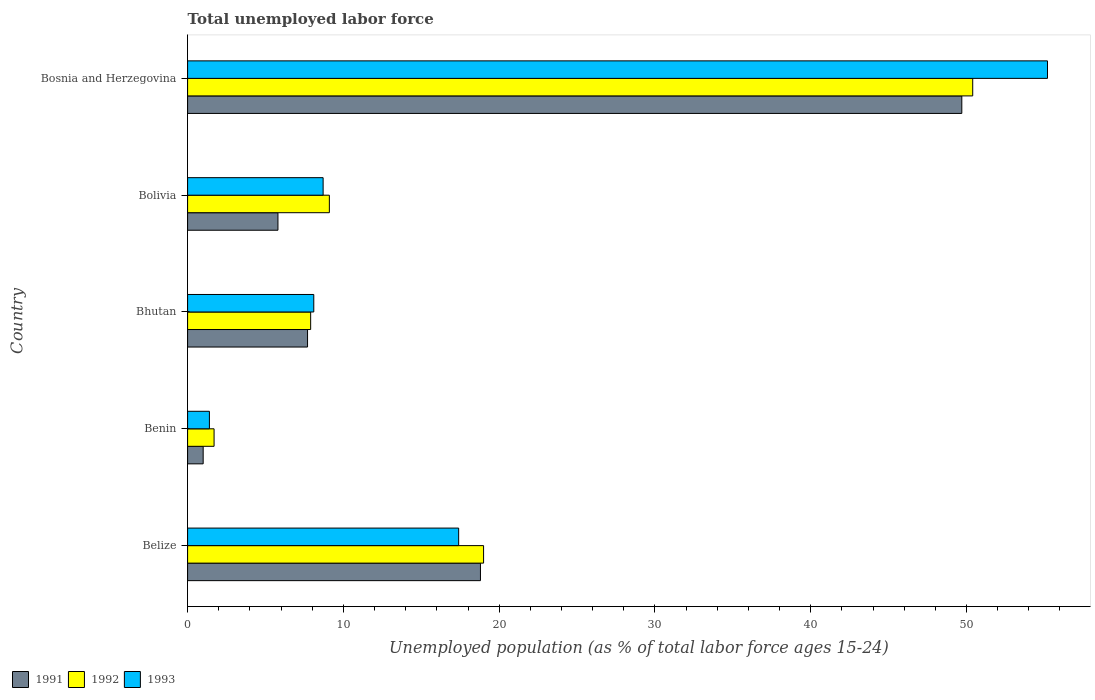How many bars are there on the 4th tick from the top?
Offer a terse response. 3. How many bars are there on the 5th tick from the bottom?
Offer a very short reply. 3. What is the label of the 4th group of bars from the top?
Provide a short and direct response. Benin. In how many cases, is the number of bars for a given country not equal to the number of legend labels?
Make the answer very short. 0. What is the percentage of unemployed population in in 1992 in Bosnia and Herzegovina?
Make the answer very short. 50.4. Across all countries, what is the maximum percentage of unemployed population in in 1991?
Offer a terse response. 49.7. In which country was the percentage of unemployed population in in 1992 maximum?
Make the answer very short. Bosnia and Herzegovina. In which country was the percentage of unemployed population in in 1991 minimum?
Provide a short and direct response. Benin. What is the total percentage of unemployed population in in 1993 in the graph?
Your response must be concise. 90.8. What is the difference between the percentage of unemployed population in in 1992 in Belize and that in Bolivia?
Keep it short and to the point. 9.9. What is the difference between the percentage of unemployed population in in 1992 in Bolivia and the percentage of unemployed population in in 1991 in Benin?
Provide a succinct answer. 8.1. What is the difference between the percentage of unemployed population in in 1993 and percentage of unemployed population in in 1991 in Belize?
Offer a terse response. -1.4. What is the ratio of the percentage of unemployed population in in 1993 in Benin to that in Bosnia and Herzegovina?
Your response must be concise. 0.03. Is the percentage of unemployed population in in 1991 in Belize less than that in Benin?
Offer a very short reply. No. What is the difference between the highest and the second highest percentage of unemployed population in in 1992?
Make the answer very short. 31.4. What is the difference between the highest and the lowest percentage of unemployed population in in 1993?
Make the answer very short. 53.8. In how many countries, is the percentage of unemployed population in in 1992 greater than the average percentage of unemployed population in in 1992 taken over all countries?
Ensure brevity in your answer.  2. Is the sum of the percentage of unemployed population in in 1991 in Belize and Benin greater than the maximum percentage of unemployed population in in 1992 across all countries?
Offer a terse response. No. What does the 2nd bar from the top in Belize represents?
Give a very brief answer. 1992. What does the 1st bar from the bottom in Bolivia represents?
Offer a very short reply. 1991. Are all the bars in the graph horizontal?
Ensure brevity in your answer.  Yes. How many countries are there in the graph?
Offer a very short reply. 5. What is the difference between two consecutive major ticks on the X-axis?
Ensure brevity in your answer.  10. Does the graph contain any zero values?
Make the answer very short. No. Where does the legend appear in the graph?
Make the answer very short. Bottom left. How many legend labels are there?
Give a very brief answer. 3. What is the title of the graph?
Make the answer very short. Total unemployed labor force. Does "2006" appear as one of the legend labels in the graph?
Offer a terse response. No. What is the label or title of the X-axis?
Make the answer very short. Unemployed population (as % of total labor force ages 15-24). What is the label or title of the Y-axis?
Ensure brevity in your answer.  Country. What is the Unemployed population (as % of total labor force ages 15-24) of 1991 in Belize?
Offer a terse response. 18.8. What is the Unemployed population (as % of total labor force ages 15-24) of 1992 in Belize?
Provide a succinct answer. 19. What is the Unemployed population (as % of total labor force ages 15-24) of 1993 in Belize?
Offer a very short reply. 17.4. What is the Unemployed population (as % of total labor force ages 15-24) in 1992 in Benin?
Offer a very short reply. 1.7. What is the Unemployed population (as % of total labor force ages 15-24) of 1993 in Benin?
Give a very brief answer. 1.4. What is the Unemployed population (as % of total labor force ages 15-24) in 1991 in Bhutan?
Provide a succinct answer. 7.7. What is the Unemployed population (as % of total labor force ages 15-24) of 1992 in Bhutan?
Your response must be concise. 7.9. What is the Unemployed population (as % of total labor force ages 15-24) in 1993 in Bhutan?
Provide a short and direct response. 8.1. What is the Unemployed population (as % of total labor force ages 15-24) in 1991 in Bolivia?
Your answer should be compact. 5.8. What is the Unemployed population (as % of total labor force ages 15-24) of 1992 in Bolivia?
Offer a very short reply. 9.1. What is the Unemployed population (as % of total labor force ages 15-24) in 1993 in Bolivia?
Your answer should be compact. 8.7. What is the Unemployed population (as % of total labor force ages 15-24) in 1991 in Bosnia and Herzegovina?
Give a very brief answer. 49.7. What is the Unemployed population (as % of total labor force ages 15-24) of 1992 in Bosnia and Herzegovina?
Make the answer very short. 50.4. What is the Unemployed population (as % of total labor force ages 15-24) of 1993 in Bosnia and Herzegovina?
Provide a short and direct response. 55.2. Across all countries, what is the maximum Unemployed population (as % of total labor force ages 15-24) in 1991?
Make the answer very short. 49.7. Across all countries, what is the maximum Unemployed population (as % of total labor force ages 15-24) of 1992?
Give a very brief answer. 50.4. Across all countries, what is the maximum Unemployed population (as % of total labor force ages 15-24) in 1993?
Make the answer very short. 55.2. Across all countries, what is the minimum Unemployed population (as % of total labor force ages 15-24) of 1991?
Provide a short and direct response. 1. Across all countries, what is the minimum Unemployed population (as % of total labor force ages 15-24) in 1992?
Keep it short and to the point. 1.7. Across all countries, what is the minimum Unemployed population (as % of total labor force ages 15-24) in 1993?
Offer a very short reply. 1.4. What is the total Unemployed population (as % of total labor force ages 15-24) of 1992 in the graph?
Keep it short and to the point. 88.1. What is the total Unemployed population (as % of total labor force ages 15-24) of 1993 in the graph?
Ensure brevity in your answer.  90.8. What is the difference between the Unemployed population (as % of total labor force ages 15-24) in 1991 in Belize and that in Benin?
Offer a very short reply. 17.8. What is the difference between the Unemployed population (as % of total labor force ages 15-24) of 1992 in Belize and that in Benin?
Provide a short and direct response. 17.3. What is the difference between the Unemployed population (as % of total labor force ages 15-24) in 1992 in Belize and that in Bhutan?
Offer a terse response. 11.1. What is the difference between the Unemployed population (as % of total labor force ages 15-24) of 1993 in Belize and that in Bhutan?
Your answer should be compact. 9.3. What is the difference between the Unemployed population (as % of total labor force ages 15-24) in 1992 in Belize and that in Bolivia?
Offer a very short reply. 9.9. What is the difference between the Unemployed population (as % of total labor force ages 15-24) in 1991 in Belize and that in Bosnia and Herzegovina?
Offer a very short reply. -30.9. What is the difference between the Unemployed population (as % of total labor force ages 15-24) in 1992 in Belize and that in Bosnia and Herzegovina?
Provide a short and direct response. -31.4. What is the difference between the Unemployed population (as % of total labor force ages 15-24) of 1993 in Belize and that in Bosnia and Herzegovina?
Keep it short and to the point. -37.8. What is the difference between the Unemployed population (as % of total labor force ages 15-24) in 1992 in Benin and that in Bhutan?
Ensure brevity in your answer.  -6.2. What is the difference between the Unemployed population (as % of total labor force ages 15-24) in 1993 in Benin and that in Bhutan?
Provide a succinct answer. -6.7. What is the difference between the Unemployed population (as % of total labor force ages 15-24) of 1991 in Benin and that in Bolivia?
Give a very brief answer. -4.8. What is the difference between the Unemployed population (as % of total labor force ages 15-24) in 1992 in Benin and that in Bolivia?
Offer a terse response. -7.4. What is the difference between the Unemployed population (as % of total labor force ages 15-24) in 1993 in Benin and that in Bolivia?
Your response must be concise. -7.3. What is the difference between the Unemployed population (as % of total labor force ages 15-24) of 1991 in Benin and that in Bosnia and Herzegovina?
Your answer should be very brief. -48.7. What is the difference between the Unemployed population (as % of total labor force ages 15-24) of 1992 in Benin and that in Bosnia and Herzegovina?
Provide a succinct answer. -48.7. What is the difference between the Unemployed population (as % of total labor force ages 15-24) of 1993 in Benin and that in Bosnia and Herzegovina?
Ensure brevity in your answer.  -53.8. What is the difference between the Unemployed population (as % of total labor force ages 15-24) in 1991 in Bhutan and that in Bolivia?
Your response must be concise. 1.9. What is the difference between the Unemployed population (as % of total labor force ages 15-24) of 1992 in Bhutan and that in Bolivia?
Keep it short and to the point. -1.2. What is the difference between the Unemployed population (as % of total labor force ages 15-24) in 1991 in Bhutan and that in Bosnia and Herzegovina?
Your response must be concise. -42. What is the difference between the Unemployed population (as % of total labor force ages 15-24) of 1992 in Bhutan and that in Bosnia and Herzegovina?
Give a very brief answer. -42.5. What is the difference between the Unemployed population (as % of total labor force ages 15-24) in 1993 in Bhutan and that in Bosnia and Herzegovina?
Keep it short and to the point. -47.1. What is the difference between the Unemployed population (as % of total labor force ages 15-24) of 1991 in Bolivia and that in Bosnia and Herzegovina?
Your answer should be compact. -43.9. What is the difference between the Unemployed population (as % of total labor force ages 15-24) of 1992 in Bolivia and that in Bosnia and Herzegovina?
Make the answer very short. -41.3. What is the difference between the Unemployed population (as % of total labor force ages 15-24) of 1993 in Bolivia and that in Bosnia and Herzegovina?
Give a very brief answer. -46.5. What is the difference between the Unemployed population (as % of total labor force ages 15-24) in 1991 in Belize and the Unemployed population (as % of total labor force ages 15-24) in 1992 in Benin?
Give a very brief answer. 17.1. What is the difference between the Unemployed population (as % of total labor force ages 15-24) in 1991 in Belize and the Unemployed population (as % of total labor force ages 15-24) in 1993 in Benin?
Ensure brevity in your answer.  17.4. What is the difference between the Unemployed population (as % of total labor force ages 15-24) in 1992 in Belize and the Unemployed population (as % of total labor force ages 15-24) in 1993 in Benin?
Provide a short and direct response. 17.6. What is the difference between the Unemployed population (as % of total labor force ages 15-24) of 1991 in Belize and the Unemployed population (as % of total labor force ages 15-24) of 1992 in Bhutan?
Make the answer very short. 10.9. What is the difference between the Unemployed population (as % of total labor force ages 15-24) in 1991 in Belize and the Unemployed population (as % of total labor force ages 15-24) in 1993 in Bolivia?
Ensure brevity in your answer.  10.1. What is the difference between the Unemployed population (as % of total labor force ages 15-24) in 1991 in Belize and the Unemployed population (as % of total labor force ages 15-24) in 1992 in Bosnia and Herzegovina?
Provide a succinct answer. -31.6. What is the difference between the Unemployed population (as % of total labor force ages 15-24) of 1991 in Belize and the Unemployed population (as % of total labor force ages 15-24) of 1993 in Bosnia and Herzegovina?
Give a very brief answer. -36.4. What is the difference between the Unemployed population (as % of total labor force ages 15-24) in 1992 in Belize and the Unemployed population (as % of total labor force ages 15-24) in 1993 in Bosnia and Herzegovina?
Your answer should be very brief. -36.2. What is the difference between the Unemployed population (as % of total labor force ages 15-24) in 1991 in Benin and the Unemployed population (as % of total labor force ages 15-24) in 1992 in Bhutan?
Offer a terse response. -6.9. What is the difference between the Unemployed population (as % of total labor force ages 15-24) in 1991 in Benin and the Unemployed population (as % of total labor force ages 15-24) in 1992 in Bolivia?
Offer a terse response. -8.1. What is the difference between the Unemployed population (as % of total labor force ages 15-24) in 1991 in Benin and the Unemployed population (as % of total labor force ages 15-24) in 1993 in Bolivia?
Your response must be concise. -7.7. What is the difference between the Unemployed population (as % of total labor force ages 15-24) in 1992 in Benin and the Unemployed population (as % of total labor force ages 15-24) in 1993 in Bolivia?
Offer a terse response. -7. What is the difference between the Unemployed population (as % of total labor force ages 15-24) in 1991 in Benin and the Unemployed population (as % of total labor force ages 15-24) in 1992 in Bosnia and Herzegovina?
Offer a terse response. -49.4. What is the difference between the Unemployed population (as % of total labor force ages 15-24) of 1991 in Benin and the Unemployed population (as % of total labor force ages 15-24) of 1993 in Bosnia and Herzegovina?
Ensure brevity in your answer.  -54.2. What is the difference between the Unemployed population (as % of total labor force ages 15-24) of 1992 in Benin and the Unemployed population (as % of total labor force ages 15-24) of 1993 in Bosnia and Herzegovina?
Offer a terse response. -53.5. What is the difference between the Unemployed population (as % of total labor force ages 15-24) of 1991 in Bhutan and the Unemployed population (as % of total labor force ages 15-24) of 1992 in Bolivia?
Your response must be concise. -1.4. What is the difference between the Unemployed population (as % of total labor force ages 15-24) of 1991 in Bhutan and the Unemployed population (as % of total labor force ages 15-24) of 1992 in Bosnia and Herzegovina?
Provide a succinct answer. -42.7. What is the difference between the Unemployed population (as % of total labor force ages 15-24) of 1991 in Bhutan and the Unemployed population (as % of total labor force ages 15-24) of 1993 in Bosnia and Herzegovina?
Ensure brevity in your answer.  -47.5. What is the difference between the Unemployed population (as % of total labor force ages 15-24) in 1992 in Bhutan and the Unemployed population (as % of total labor force ages 15-24) in 1993 in Bosnia and Herzegovina?
Provide a succinct answer. -47.3. What is the difference between the Unemployed population (as % of total labor force ages 15-24) of 1991 in Bolivia and the Unemployed population (as % of total labor force ages 15-24) of 1992 in Bosnia and Herzegovina?
Give a very brief answer. -44.6. What is the difference between the Unemployed population (as % of total labor force ages 15-24) of 1991 in Bolivia and the Unemployed population (as % of total labor force ages 15-24) of 1993 in Bosnia and Herzegovina?
Provide a succinct answer. -49.4. What is the difference between the Unemployed population (as % of total labor force ages 15-24) of 1992 in Bolivia and the Unemployed population (as % of total labor force ages 15-24) of 1993 in Bosnia and Herzegovina?
Offer a very short reply. -46.1. What is the average Unemployed population (as % of total labor force ages 15-24) of 1992 per country?
Give a very brief answer. 17.62. What is the average Unemployed population (as % of total labor force ages 15-24) of 1993 per country?
Your answer should be very brief. 18.16. What is the difference between the Unemployed population (as % of total labor force ages 15-24) in 1991 and Unemployed population (as % of total labor force ages 15-24) in 1992 in Belize?
Give a very brief answer. -0.2. What is the difference between the Unemployed population (as % of total labor force ages 15-24) in 1991 and Unemployed population (as % of total labor force ages 15-24) in 1993 in Benin?
Provide a succinct answer. -0.4. What is the difference between the Unemployed population (as % of total labor force ages 15-24) in 1992 and Unemployed population (as % of total labor force ages 15-24) in 1993 in Benin?
Give a very brief answer. 0.3. What is the difference between the Unemployed population (as % of total labor force ages 15-24) of 1991 and Unemployed population (as % of total labor force ages 15-24) of 1992 in Bhutan?
Offer a terse response. -0.2. What is the difference between the Unemployed population (as % of total labor force ages 15-24) of 1992 and Unemployed population (as % of total labor force ages 15-24) of 1993 in Bhutan?
Keep it short and to the point. -0.2. What is the difference between the Unemployed population (as % of total labor force ages 15-24) of 1992 and Unemployed population (as % of total labor force ages 15-24) of 1993 in Bolivia?
Offer a very short reply. 0.4. What is the difference between the Unemployed population (as % of total labor force ages 15-24) in 1991 and Unemployed population (as % of total labor force ages 15-24) in 1992 in Bosnia and Herzegovina?
Your answer should be very brief. -0.7. What is the ratio of the Unemployed population (as % of total labor force ages 15-24) in 1991 in Belize to that in Benin?
Offer a very short reply. 18.8. What is the ratio of the Unemployed population (as % of total labor force ages 15-24) of 1992 in Belize to that in Benin?
Offer a very short reply. 11.18. What is the ratio of the Unemployed population (as % of total labor force ages 15-24) of 1993 in Belize to that in Benin?
Offer a terse response. 12.43. What is the ratio of the Unemployed population (as % of total labor force ages 15-24) in 1991 in Belize to that in Bhutan?
Provide a short and direct response. 2.44. What is the ratio of the Unemployed population (as % of total labor force ages 15-24) in 1992 in Belize to that in Bhutan?
Your answer should be very brief. 2.41. What is the ratio of the Unemployed population (as % of total labor force ages 15-24) in 1993 in Belize to that in Bhutan?
Give a very brief answer. 2.15. What is the ratio of the Unemployed population (as % of total labor force ages 15-24) of 1991 in Belize to that in Bolivia?
Offer a very short reply. 3.24. What is the ratio of the Unemployed population (as % of total labor force ages 15-24) of 1992 in Belize to that in Bolivia?
Keep it short and to the point. 2.09. What is the ratio of the Unemployed population (as % of total labor force ages 15-24) of 1993 in Belize to that in Bolivia?
Ensure brevity in your answer.  2. What is the ratio of the Unemployed population (as % of total labor force ages 15-24) of 1991 in Belize to that in Bosnia and Herzegovina?
Your answer should be compact. 0.38. What is the ratio of the Unemployed population (as % of total labor force ages 15-24) in 1992 in Belize to that in Bosnia and Herzegovina?
Your response must be concise. 0.38. What is the ratio of the Unemployed population (as % of total labor force ages 15-24) in 1993 in Belize to that in Bosnia and Herzegovina?
Provide a succinct answer. 0.32. What is the ratio of the Unemployed population (as % of total labor force ages 15-24) in 1991 in Benin to that in Bhutan?
Provide a succinct answer. 0.13. What is the ratio of the Unemployed population (as % of total labor force ages 15-24) in 1992 in Benin to that in Bhutan?
Offer a terse response. 0.22. What is the ratio of the Unemployed population (as % of total labor force ages 15-24) in 1993 in Benin to that in Bhutan?
Your response must be concise. 0.17. What is the ratio of the Unemployed population (as % of total labor force ages 15-24) of 1991 in Benin to that in Bolivia?
Give a very brief answer. 0.17. What is the ratio of the Unemployed population (as % of total labor force ages 15-24) of 1992 in Benin to that in Bolivia?
Offer a very short reply. 0.19. What is the ratio of the Unemployed population (as % of total labor force ages 15-24) of 1993 in Benin to that in Bolivia?
Make the answer very short. 0.16. What is the ratio of the Unemployed population (as % of total labor force ages 15-24) in 1991 in Benin to that in Bosnia and Herzegovina?
Your answer should be very brief. 0.02. What is the ratio of the Unemployed population (as % of total labor force ages 15-24) in 1992 in Benin to that in Bosnia and Herzegovina?
Give a very brief answer. 0.03. What is the ratio of the Unemployed population (as % of total labor force ages 15-24) of 1993 in Benin to that in Bosnia and Herzegovina?
Give a very brief answer. 0.03. What is the ratio of the Unemployed population (as % of total labor force ages 15-24) in 1991 in Bhutan to that in Bolivia?
Offer a terse response. 1.33. What is the ratio of the Unemployed population (as % of total labor force ages 15-24) in 1992 in Bhutan to that in Bolivia?
Offer a very short reply. 0.87. What is the ratio of the Unemployed population (as % of total labor force ages 15-24) in 1993 in Bhutan to that in Bolivia?
Your response must be concise. 0.93. What is the ratio of the Unemployed population (as % of total labor force ages 15-24) in 1991 in Bhutan to that in Bosnia and Herzegovina?
Ensure brevity in your answer.  0.15. What is the ratio of the Unemployed population (as % of total labor force ages 15-24) of 1992 in Bhutan to that in Bosnia and Herzegovina?
Provide a succinct answer. 0.16. What is the ratio of the Unemployed population (as % of total labor force ages 15-24) of 1993 in Bhutan to that in Bosnia and Herzegovina?
Give a very brief answer. 0.15. What is the ratio of the Unemployed population (as % of total labor force ages 15-24) of 1991 in Bolivia to that in Bosnia and Herzegovina?
Your answer should be very brief. 0.12. What is the ratio of the Unemployed population (as % of total labor force ages 15-24) in 1992 in Bolivia to that in Bosnia and Herzegovina?
Give a very brief answer. 0.18. What is the ratio of the Unemployed population (as % of total labor force ages 15-24) in 1993 in Bolivia to that in Bosnia and Herzegovina?
Your answer should be very brief. 0.16. What is the difference between the highest and the second highest Unemployed population (as % of total labor force ages 15-24) of 1991?
Provide a short and direct response. 30.9. What is the difference between the highest and the second highest Unemployed population (as % of total labor force ages 15-24) of 1992?
Keep it short and to the point. 31.4. What is the difference between the highest and the second highest Unemployed population (as % of total labor force ages 15-24) of 1993?
Your response must be concise. 37.8. What is the difference between the highest and the lowest Unemployed population (as % of total labor force ages 15-24) in 1991?
Your response must be concise. 48.7. What is the difference between the highest and the lowest Unemployed population (as % of total labor force ages 15-24) in 1992?
Provide a succinct answer. 48.7. What is the difference between the highest and the lowest Unemployed population (as % of total labor force ages 15-24) of 1993?
Your answer should be compact. 53.8. 